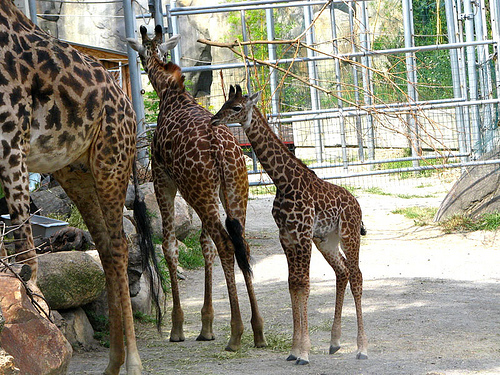What are the noticeable differences between the two giraffes apart from their size? The most noticeable differences include the pattern of their spots, the shade of their coats, and the length of their ossicones. The smaller one has lighter spots with smoother edges and shorter ossicones, which can indicate its younger age. 